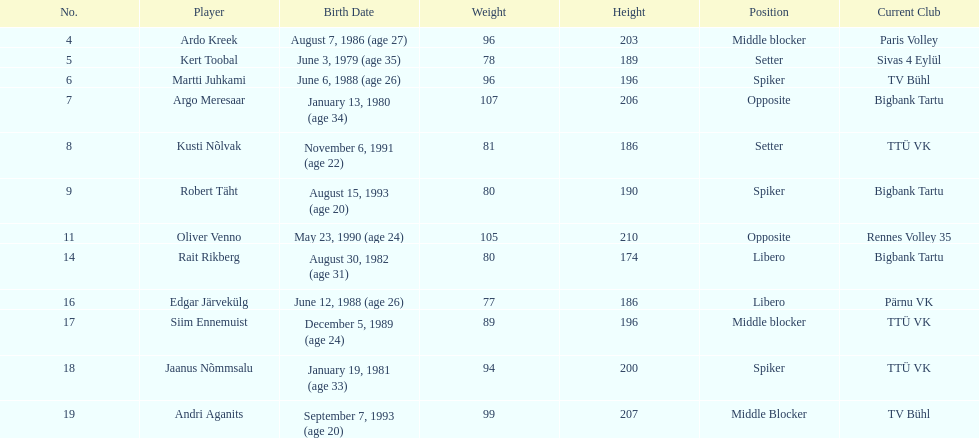Which athletes occupied the same role as ardo kreek? Siim Ennemuist, Andri Aganits. 